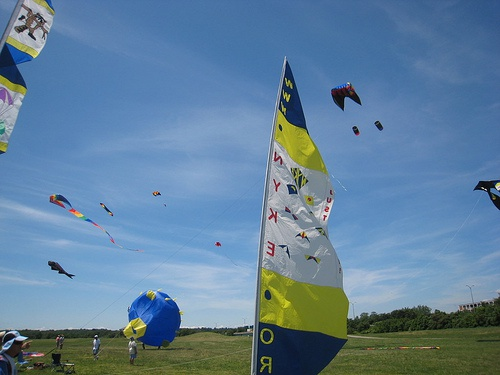Describe the objects in this image and their specific colors. I can see kite in gray, darkgray, black, and olive tones, kite in gray, darkgray, and navy tones, kite in gray, navy, blue, darkblue, and olive tones, people in gray, black, blue, and navy tones, and kite in gray, black, and maroon tones in this image. 